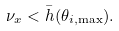<formula> <loc_0><loc_0><loc_500><loc_500>\nu _ { x } < \bar { h } ( \theta _ { i , \max } ) .</formula> 